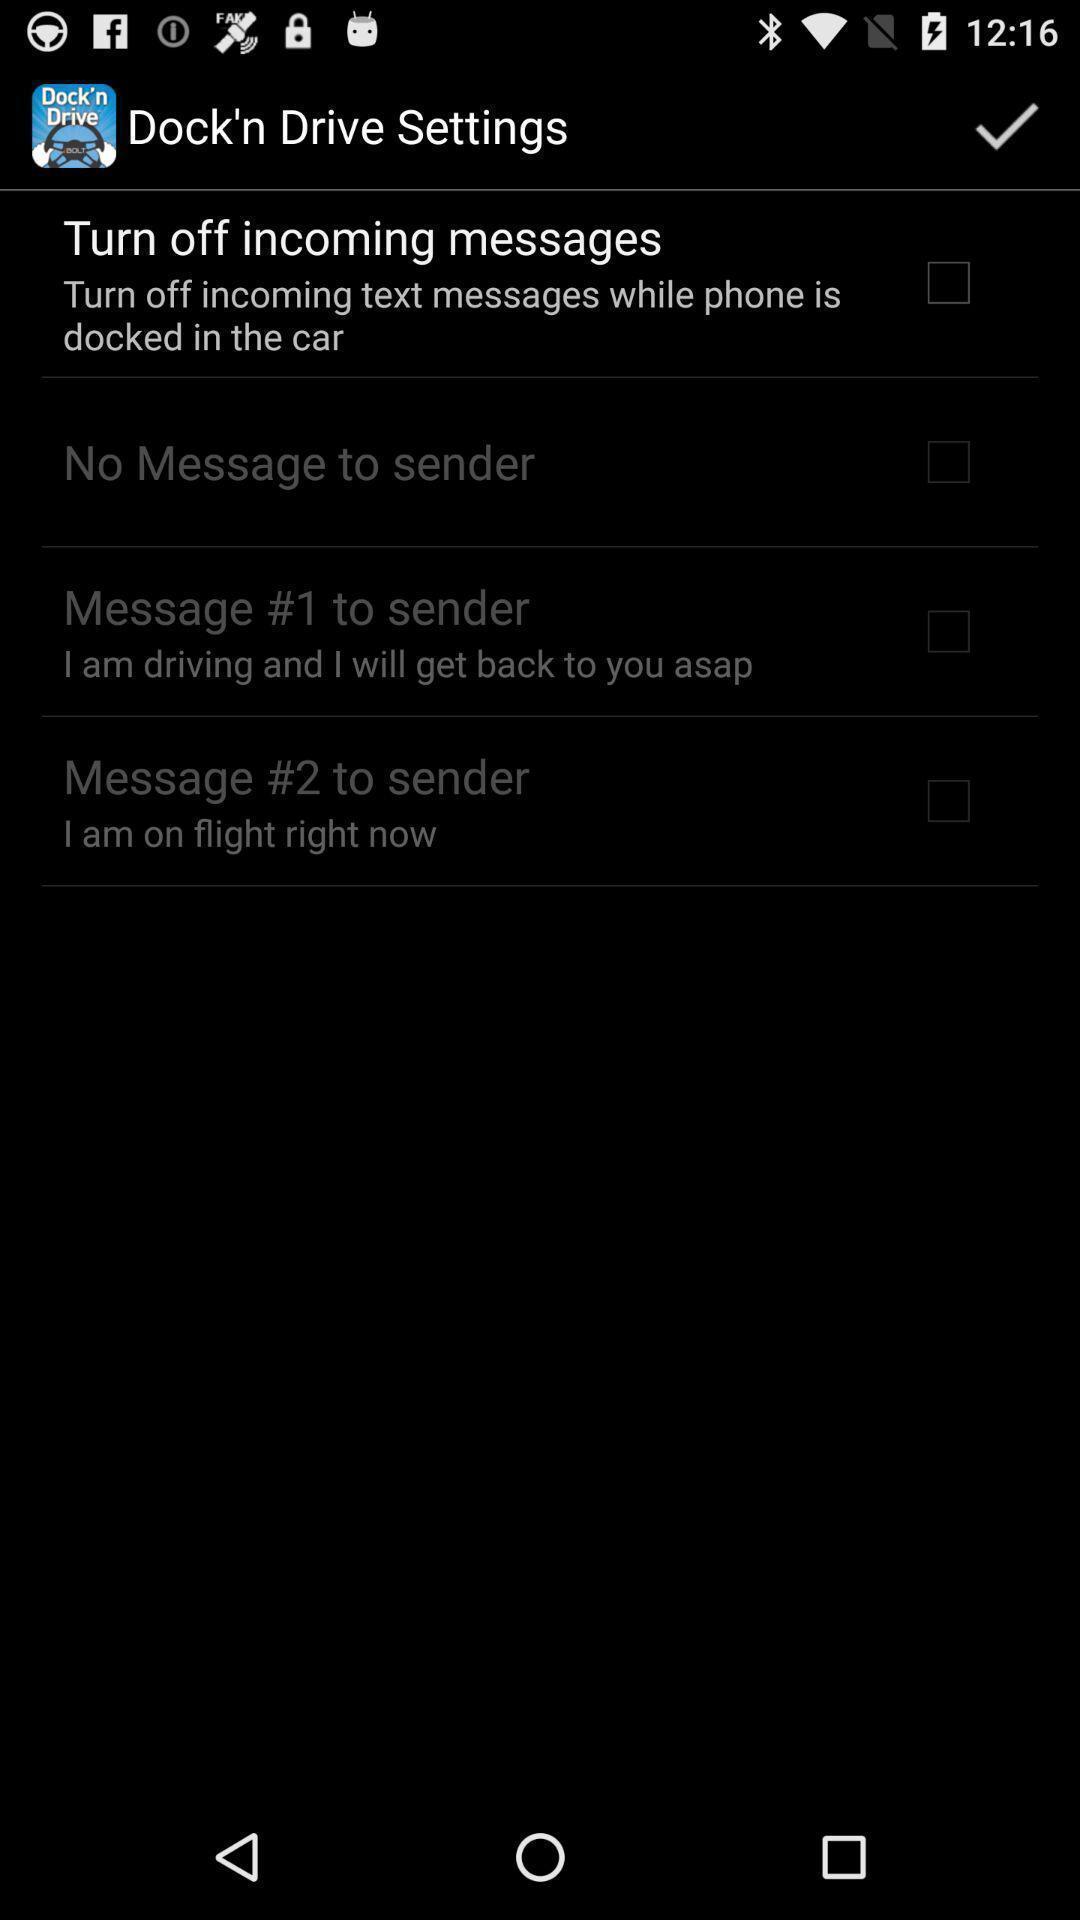Describe the key features of this screenshot. Screen shows settings. 